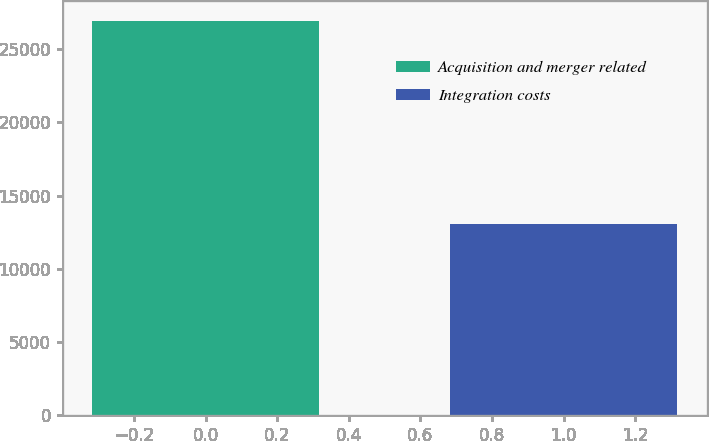Convert chart. <chart><loc_0><loc_0><loc_500><loc_500><bar_chart><fcel>Acquisition and merger related<fcel>Integration costs<nl><fcel>26969<fcel>13057<nl></chart> 